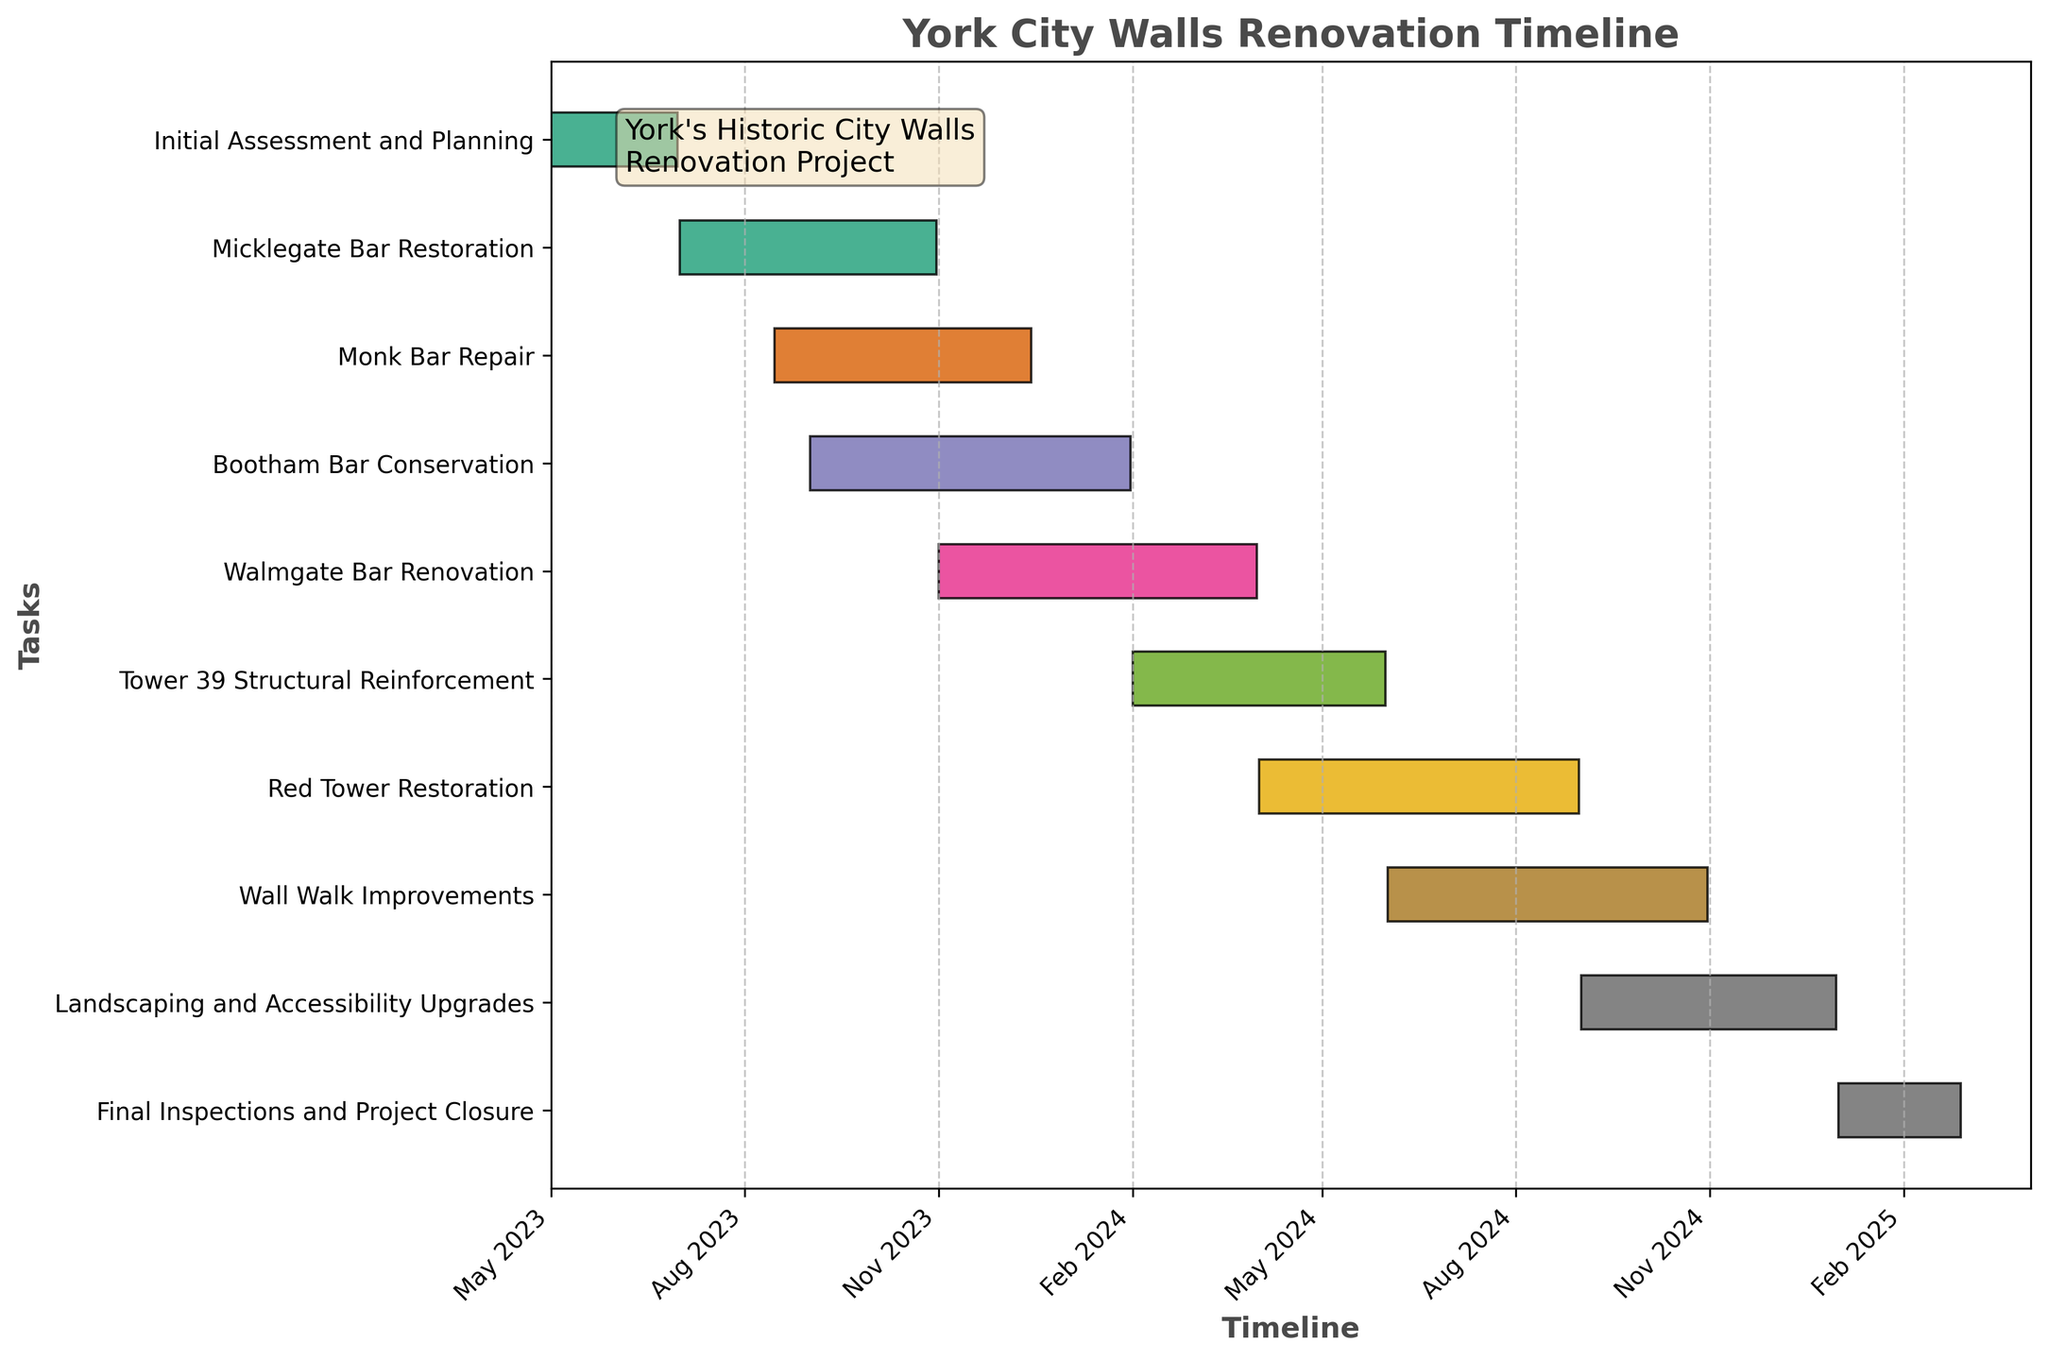What is the title of the chart? The title of the chart can be easily identified at the top of the figure. It summarizes the purpose or content of the chart.
Answer: York City Walls Renovation Timeline What is the duration of the "Final Inspections and Project Closure" phase? Look at the start date and end date for the "Final Inspections and Project Closure" phase. The duration is calculated by finding the difference between these dates.
Answer: 58 days Which phase starts immediately after "Micklegate Bar Restoration"? Observe the end date of "Micklegate Bar Restoration" and identify which phase has a start date that closely follows this end date.
Answer: Monk Bar Repair What is the total time span covered by the entire renovation project? Note the earliest start date and the latest end date across all phases. Calculate the total timespan from the earliest start to the latest end.
Answer: May 2023 to February 2025 Which renovation task has the longest duration? Compare the duration of each task, which is the difference between its start and end dates. Identify the task with the maximum duration.
Answer: Red Tower Restoration How many phases extend into the year 2025? Check the end dates of all phases and count how many extend into the year 2025.
Answer: 1 Which tasks overlap with "Bootham Bar Conservation"? Identify the start and end dates of "Bootham Bar Conservation" and find other tasks whose timelines intersect with these dates.
Answer: Monk Bar Repair, Walmgate Bar Renovation During which months of 2024 are the most renovation tasks being carried out simultaneously? Note all the tasks active in 2024, and identify the month where the maximum number of tasks overlap.
Answer: April 2024 How long is the gap between "Wall Walk Improvements" and "Landscaping and Accessibility Upgrades"? Identify the end date of "Wall Walk Improvements" and the start date of "Landscaping and Accessibility Upgrades" and calculate the difference between these dates.
Answer: 1 month 